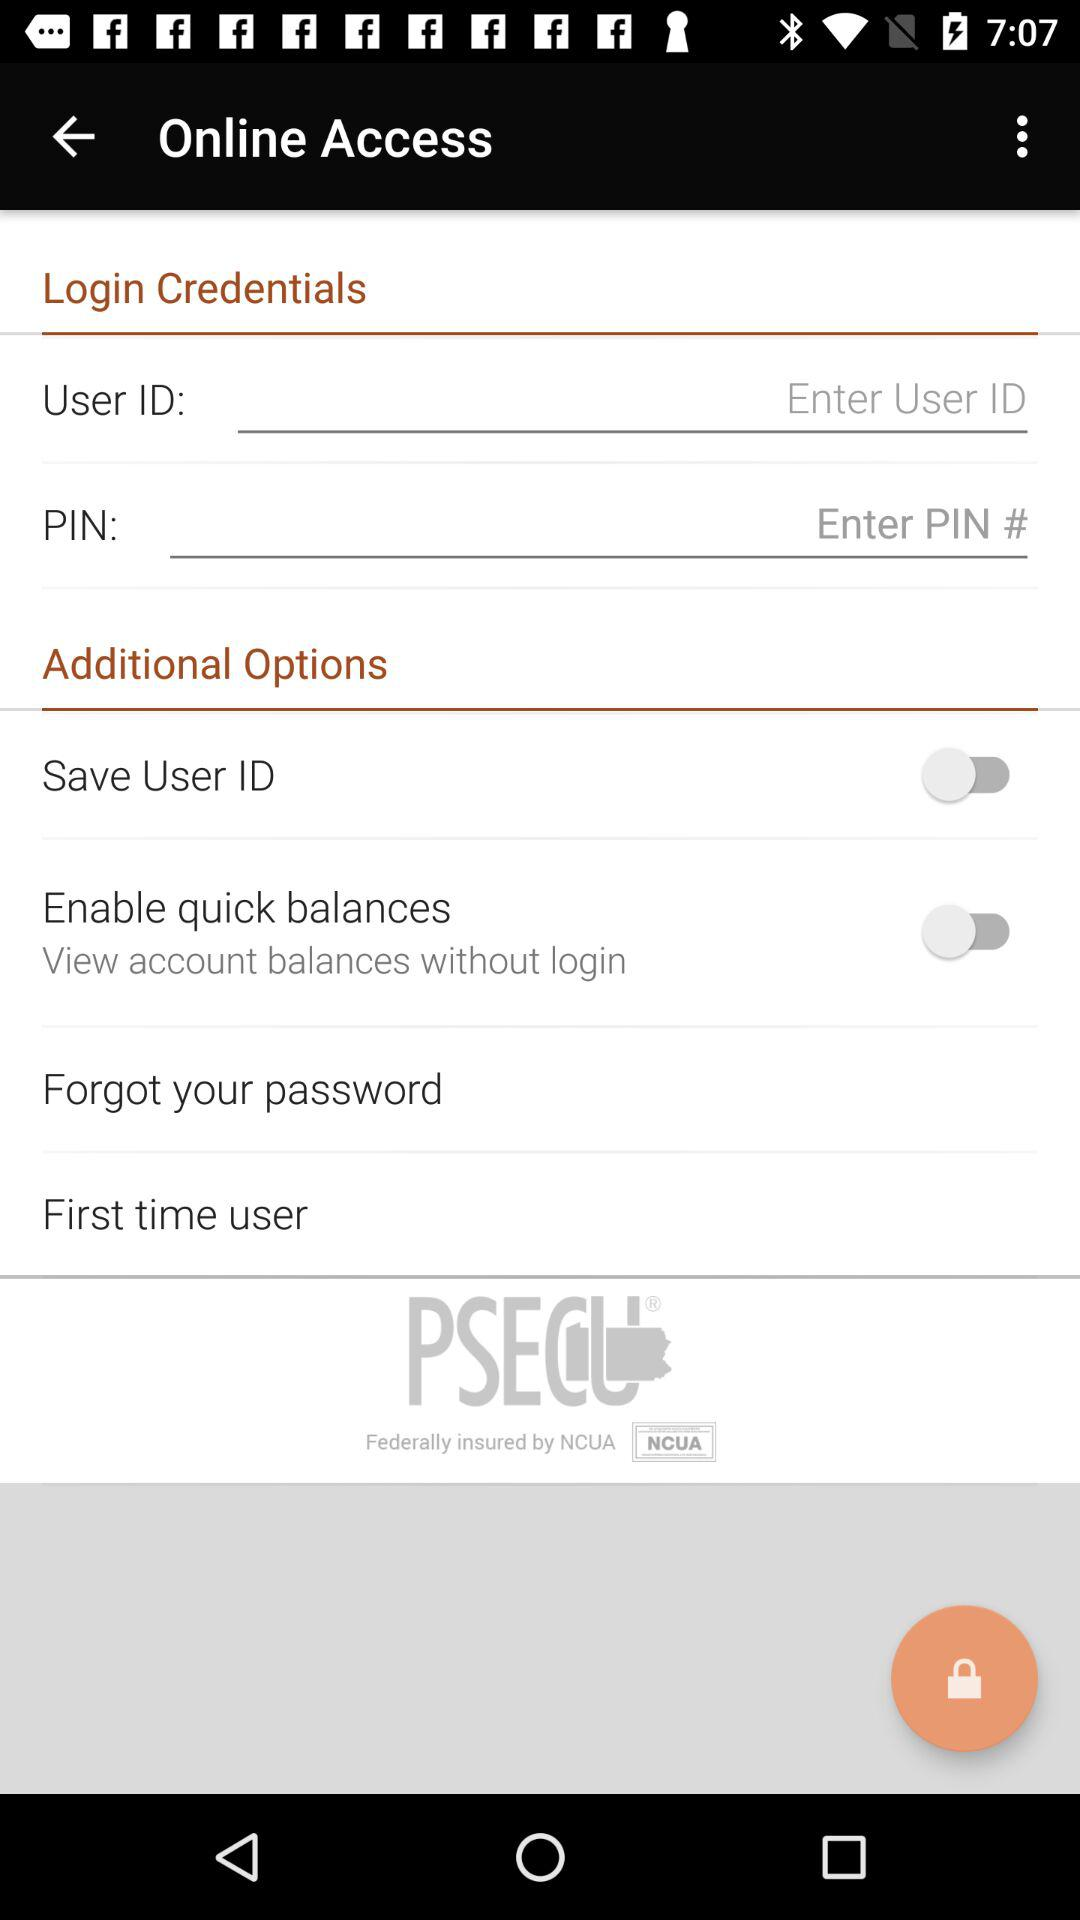What is the status of "Save User ID"? The status of "Save User ID" is "off". 